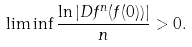Convert formula to latex. <formula><loc_0><loc_0><loc_500><loc_500>\liminf \frac { \ln | D f ^ { n } ( f ( 0 ) ) | } { n } > 0 .</formula> 